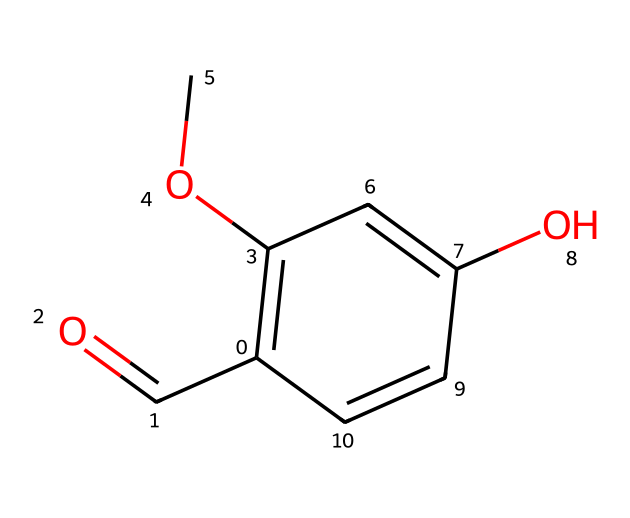What is the main functional group present in vanillin? The structure contains a formyl group (-C=O) indicated by the carbonyl oxygen double-bonded to carbon and a hydroxyl group (-OH), classifying it as an aldehyde.
Answer: aldehyde How many carbon atoms are in vanillin's structure? By analyzing the SMILES representation, each 'c' represents a carbon in the aromatic ring and there are additional carbon atoms in the methoxy group (OC) and the carbonyl group (C=O), totaling 8 carbon atoms.
Answer: 8 What is the position of the hydroxyl group in relation to the methoxy group? The hydroxyl group is in a para position relative to the methoxy group based on the carbon atoms' arrangement in the aromatic ring.
Answer: para What is the overall charge of vanillin? The molecule is neutral, as it contains no formal positive or negative charges upon examining the overall arrangement and atomic valences.
Answer: neutral How does the presence of the methoxy group affect the reactivity of vanillin? The methoxy group is an electron-donating group that increases electron density on the aromatic ring, making it more reactive towards electrophilic substitution reactions.
Answer: increases reactivity Is vanillin considered a simple or complex aromatic compound? Vanillin contains multiple functional groups and has a more intricate structure compared to simpler aromatic compounds like benzene, thus it can be classified as a complex aromatic compound.
Answer: complex 